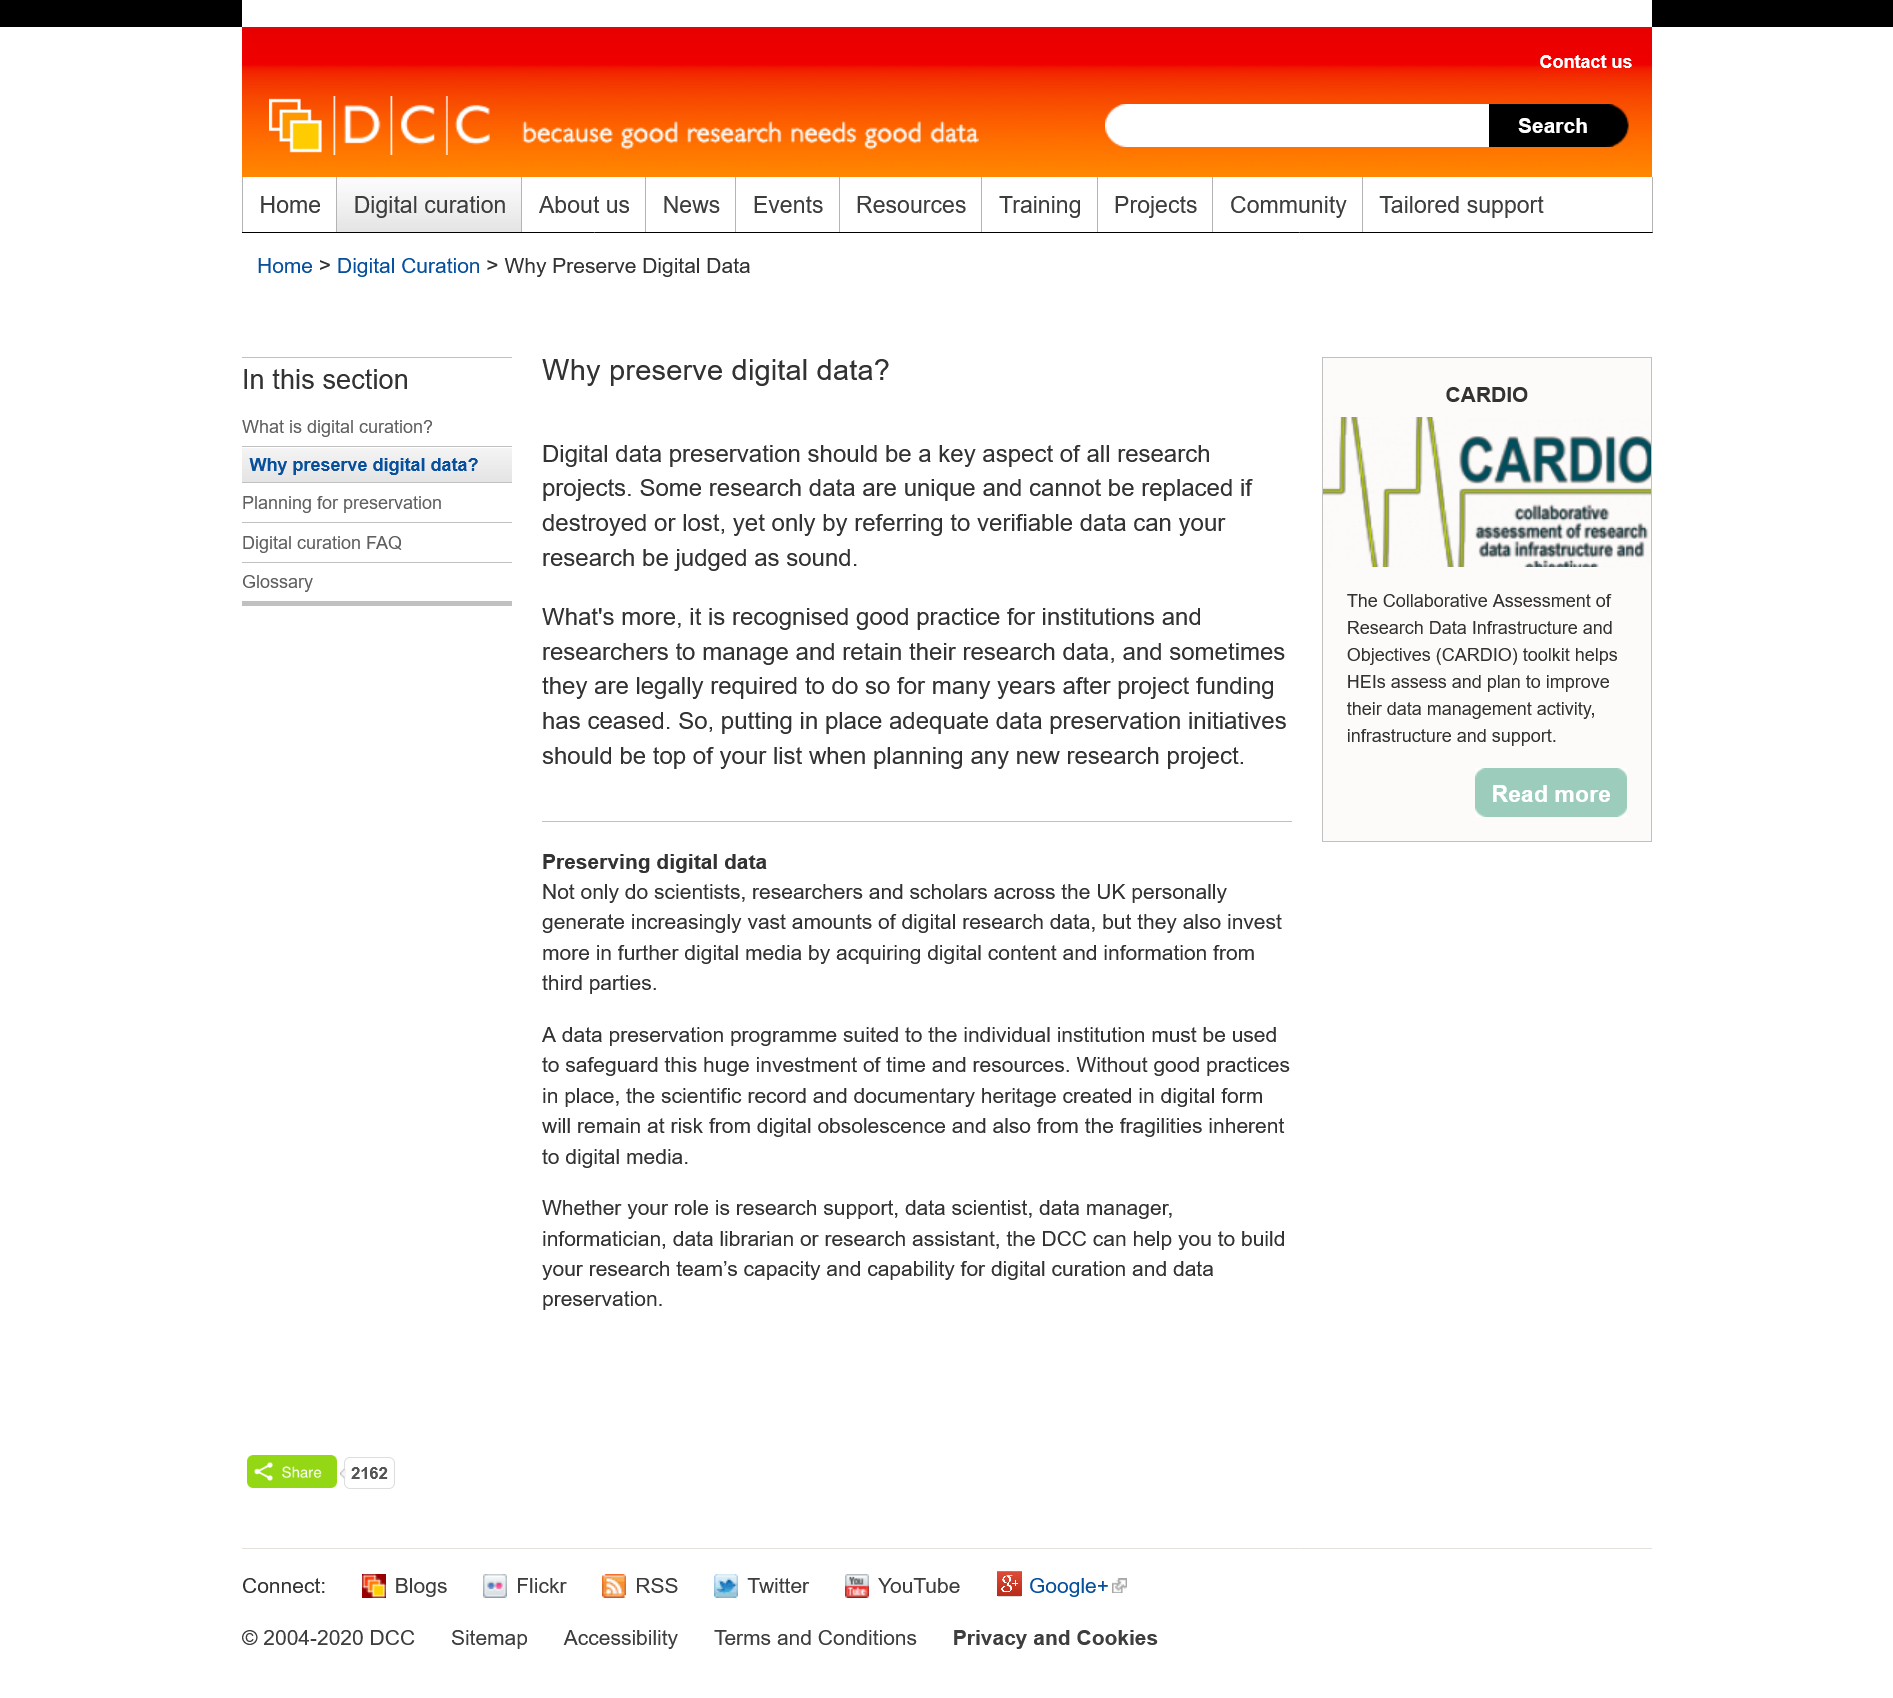Identify some key points in this picture. Yes, the DCC can assist data managers in their role. Some research data cannot be replaced if it is destroyed or lost, regardless of the efforts made to recover it. The fact that some research data are unique makes it a reason to preserve digital data. It is essential for all research projects to prioritize digital data preservation as a key aspect in order to ensure long-term access and usability. The Data and Computing Center (DCC) can assist data scientists in their roles. 